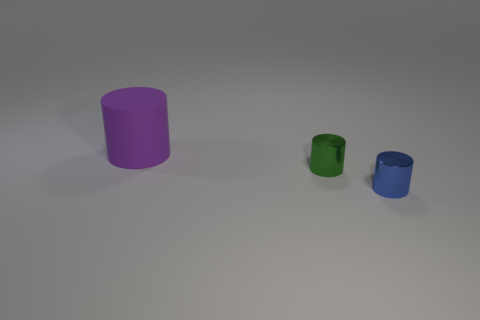Is there any other thing that has the same size as the purple object?
Your response must be concise. No. There is a shiny thing to the right of the green cylinder; is its size the same as the big matte object?
Your response must be concise. No. The tiny thing that is in front of the small green thing has what shape?
Give a very brief answer. Cylinder. Are there more large objects than yellow rubber cubes?
Make the answer very short. Yes. Is the color of the small cylinder in front of the tiny green object the same as the large rubber object?
Your answer should be very brief. No. How many things are tiny things that are in front of the green object or big cylinders behind the green cylinder?
Your answer should be compact. 2. What number of objects are on the right side of the purple rubber object and to the left of the small blue shiny thing?
Offer a terse response. 1. Does the blue object have the same material as the green thing?
Offer a very short reply. Yes. The cylinder that is in front of the large rubber cylinder and left of the small blue shiny thing is made of what material?
Give a very brief answer. Metal. The shiny cylinder left of the small metallic thing that is in front of the tiny thing that is behind the tiny blue object is what color?
Keep it short and to the point. Green. 